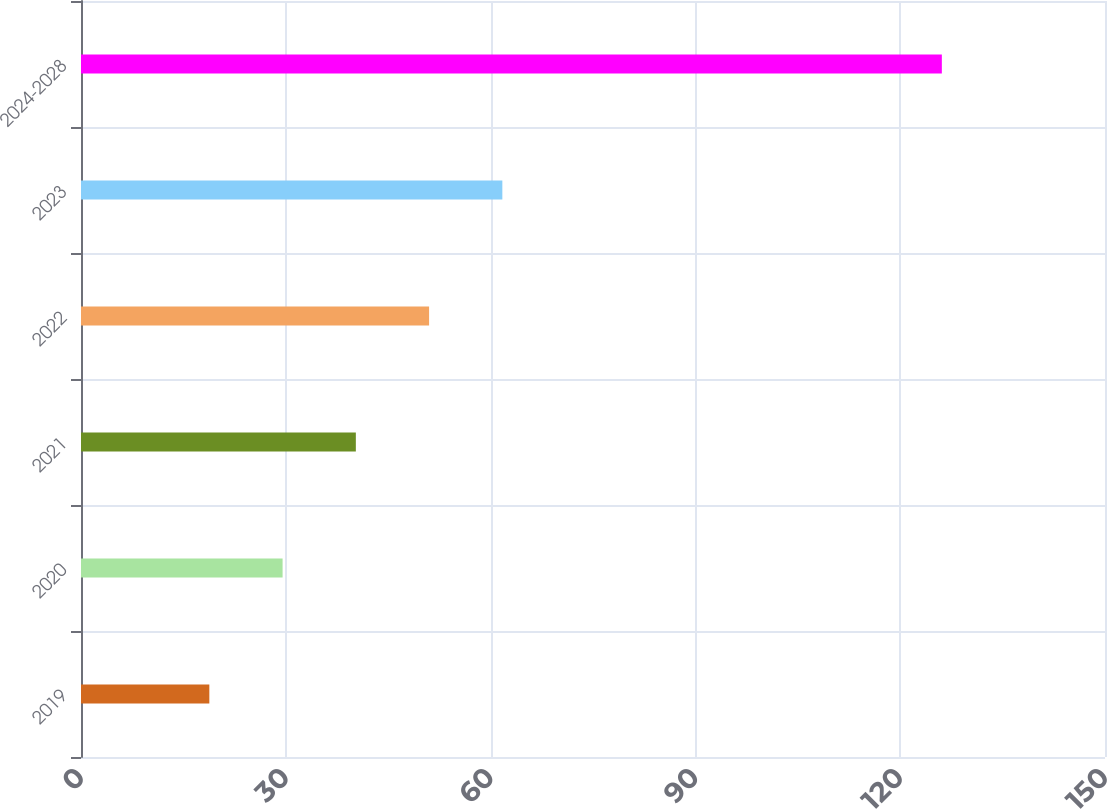Convert chart. <chart><loc_0><loc_0><loc_500><loc_500><bar_chart><fcel>2019<fcel>2020<fcel>2021<fcel>2022<fcel>2023<fcel>2024-2028<nl><fcel>18.8<fcel>29.53<fcel>40.26<fcel>50.99<fcel>61.72<fcel>126.1<nl></chart> 